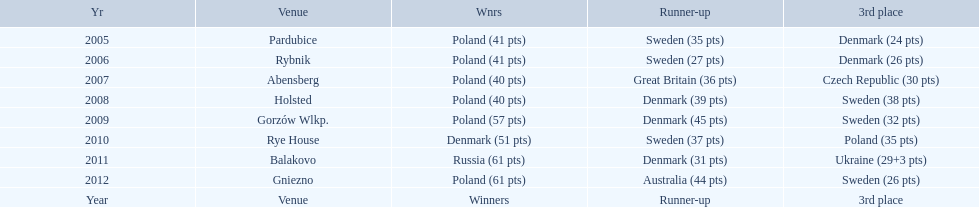After enjoying five consecutive victories at the team speedway junior world championship poland was finally unseated in what year? 2010. In that year, what teams placed first through third? Denmark (51 pts), Sweden (37 pts), Poland (35 pts). Which of those positions did poland specifically place in? 3rd place. 